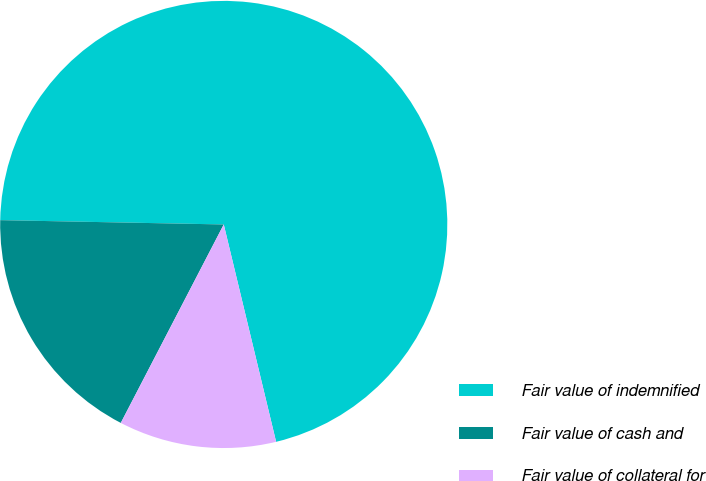Convert chart to OTSL. <chart><loc_0><loc_0><loc_500><loc_500><pie_chart><fcel>Fair value of indemnified<fcel>Fair value of cash and<fcel>Fair value of collateral for<nl><fcel>70.93%<fcel>17.69%<fcel>11.38%<nl></chart> 